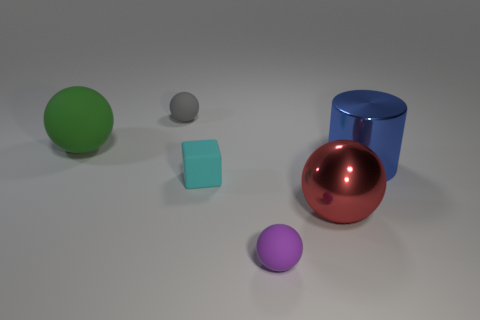Subtract all large green rubber balls. How many balls are left? 3 Subtract 1 cylinders. How many cylinders are left? 0 Add 4 large blue metal cubes. How many objects exist? 10 Subtract all gray balls. How many balls are left? 3 Add 1 big red shiny balls. How many big red shiny balls are left? 2 Add 4 purple matte balls. How many purple matte balls exist? 5 Subtract 0 green cylinders. How many objects are left? 6 Subtract all cylinders. How many objects are left? 5 Subtract all red cubes. Subtract all brown cylinders. How many cubes are left? 1 Subtract all large brown metal balls. Subtract all cyan cubes. How many objects are left? 5 